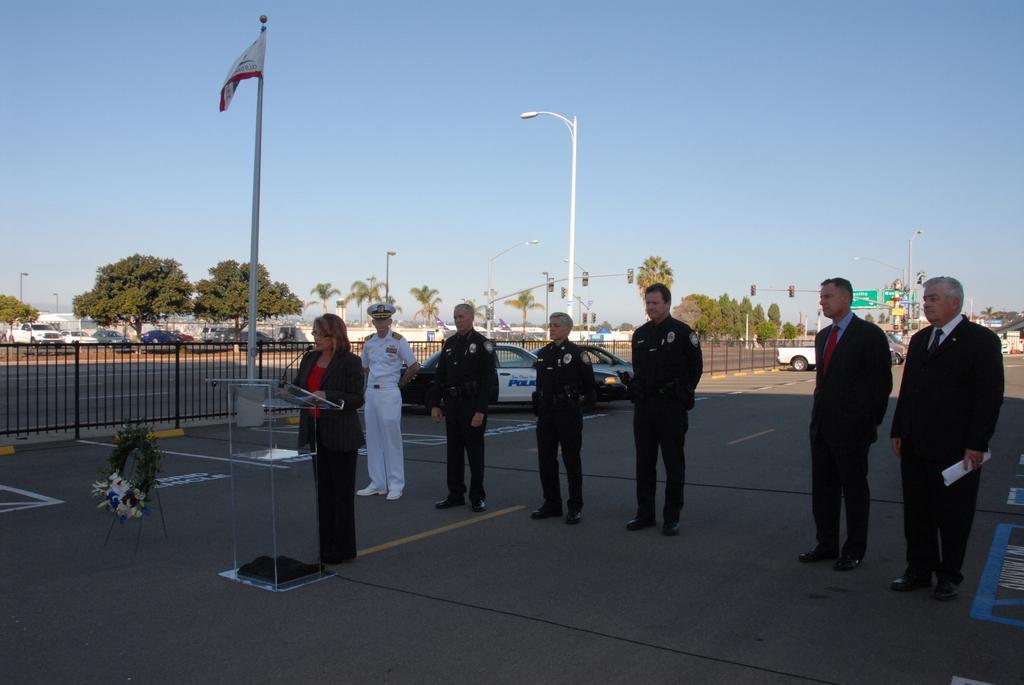Can you describe this image briefly? In this image we can see a group of people standing on the road, in front here a woman is standing, here is the podium, here is the microphone, there are cars travelling on the road, there are trees, there is the flag, there is the street light, at above here is the sky. 